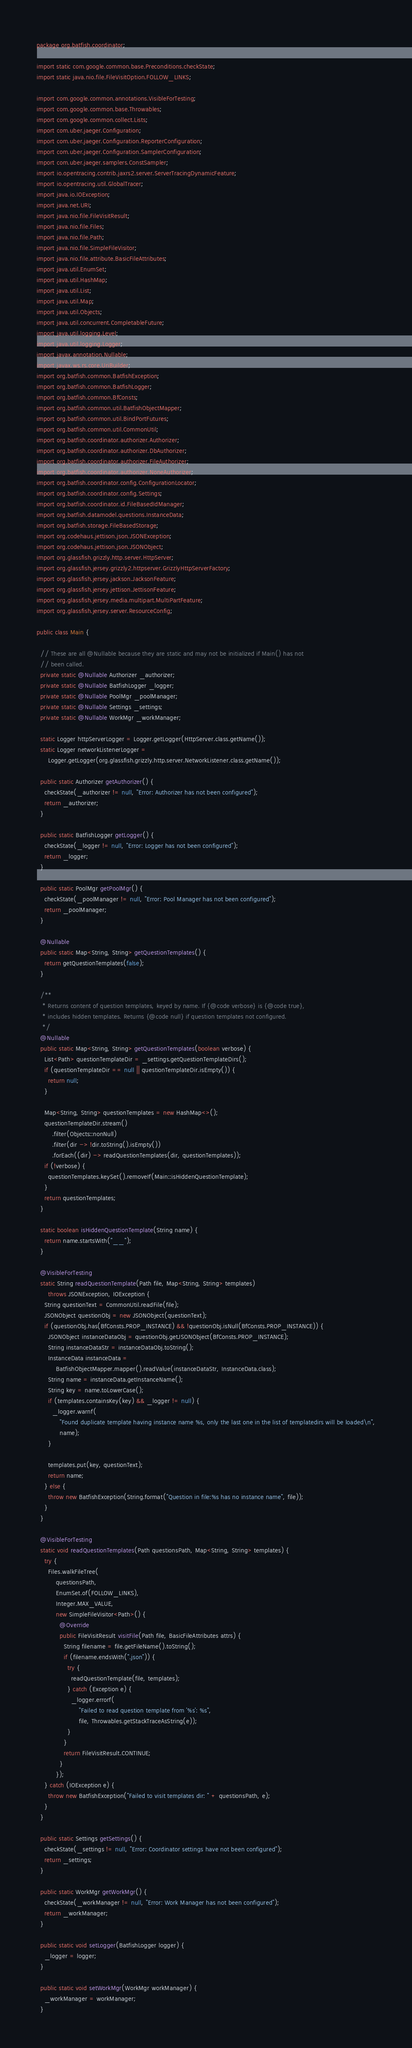<code> <loc_0><loc_0><loc_500><loc_500><_Java_>package org.batfish.coordinator;

import static com.google.common.base.Preconditions.checkState;
import static java.nio.file.FileVisitOption.FOLLOW_LINKS;

import com.google.common.annotations.VisibleForTesting;
import com.google.common.base.Throwables;
import com.google.common.collect.Lists;
import com.uber.jaeger.Configuration;
import com.uber.jaeger.Configuration.ReporterConfiguration;
import com.uber.jaeger.Configuration.SamplerConfiguration;
import com.uber.jaeger.samplers.ConstSampler;
import io.opentracing.contrib.jaxrs2.server.ServerTracingDynamicFeature;
import io.opentracing.util.GlobalTracer;
import java.io.IOException;
import java.net.URI;
import java.nio.file.FileVisitResult;
import java.nio.file.Files;
import java.nio.file.Path;
import java.nio.file.SimpleFileVisitor;
import java.nio.file.attribute.BasicFileAttributes;
import java.util.EnumSet;
import java.util.HashMap;
import java.util.List;
import java.util.Map;
import java.util.Objects;
import java.util.concurrent.CompletableFuture;
import java.util.logging.Level;
import java.util.logging.Logger;
import javax.annotation.Nullable;
import javax.ws.rs.core.UriBuilder;
import org.batfish.common.BatfishException;
import org.batfish.common.BatfishLogger;
import org.batfish.common.BfConsts;
import org.batfish.common.util.BatfishObjectMapper;
import org.batfish.common.util.BindPortFutures;
import org.batfish.common.util.CommonUtil;
import org.batfish.coordinator.authorizer.Authorizer;
import org.batfish.coordinator.authorizer.DbAuthorizer;
import org.batfish.coordinator.authorizer.FileAuthorizer;
import org.batfish.coordinator.authorizer.NoneAuthorizer;
import org.batfish.coordinator.config.ConfigurationLocator;
import org.batfish.coordinator.config.Settings;
import org.batfish.coordinator.id.FileBasedIdManager;
import org.batfish.datamodel.questions.InstanceData;
import org.batfish.storage.FileBasedStorage;
import org.codehaus.jettison.json.JSONException;
import org.codehaus.jettison.json.JSONObject;
import org.glassfish.grizzly.http.server.HttpServer;
import org.glassfish.jersey.grizzly2.httpserver.GrizzlyHttpServerFactory;
import org.glassfish.jersey.jackson.JacksonFeature;
import org.glassfish.jersey.jettison.JettisonFeature;
import org.glassfish.jersey.media.multipart.MultiPartFeature;
import org.glassfish.jersey.server.ResourceConfig;

public class Main {

  // These are all @Nullable because they are static and may not be initialized if Main() has not
  // been called.
  private static @Nullable Authorizer _authorizer;
  private static @Nullable BatfishLogger _logger;
  private static @Nullable PoolMgr _poolManager;
  private static @Nullable Settings _settings;
  private static @Nullable WorkMgr _workManager;

  static Logger httpServerLogger = Logger.getLogger(HttpServer.class.getName());
  static Logger networkListenerLogger =
      Logger.getLogger(org.glassfish.grizzly.http.server.NetworkListener.class.getName());

  public static Authorizer getAuthorizer() {
    checkState(_authorizer != null, "Error: Authorizer has not been configured");
    return _authorizer;
  }

  public static BatfishLogger getLogger() {
    checkState(_logger != null, "Error: Logger has not been configured");
    return _logger;
  }

  public static PoolMgr getPoolMgr() {
    checkState(_poolManager != null, "Error: Pool Manager has not been configured");
    return _poolManager;
  }

  @Nullable
  public static Map<String, String> getQuestionTemplates() {
    return getQuestionTemplates(false);
  }

  /**
   * Returns content of question templates, keyed by name. If {@code verbose} is {@code true},
   * includes hidden templates. Returns {@code null} if question templates not configured.
   */
  @Nullable
  public static Map<String, String> getQuestionTemplates(boolean verbose) {
    List<Path> questionTemplateDir = _settings.getQuestionTemplateDirs();
    if (questionTemplateDir == null || questionTemplateDir.isEmpty()) {
      return null;
    }

    Map<String, String> questionTemplates = new HashMap<>();
    questionTemplateDir.stream()
        .filter(Objects::nonNull)
        .filter(dir -> !dir.toString().isEmpty())
        .forEach((dir) -> readQuestionTemplates(dir, questionTemplates));
    if (!verbose) {
      questionTemplates.keySet().removeIf(Main::isHiddenQuestionTemplate);
    }
    return questionTemplates;
  }

  static boolean isHiddenQuestionTemplate(String name) {
    return name.startsWith("__");
  }

  @VisibleForTesting
  static String readQuestionTemplate(Path file, Map<String, String> templates)
      throws JSONException, IOException {
    String questionText = CommonUtil.readFile(file);
    JSONObject questionObj = new JSONObject(questionText);
    if (questionObj.has(BfConsts.PROP_INSTANCE) && !questionObj.isNull(BfConsts.PROP_INSTANCE)) {
      JSONObject instanceDataObj = questionObj.getJSONObject(BfConsts.PROP_INSTANCE);
      String instanceDataStr = instanceDataObj.toString();
      InstanceData instanceData =
          BatfishObjectMapper.mapper().readValue(instanceDataStr, InstanceData.class);
      String name = instanceData.getInstanceName();
      String key = name.toLowerCase();
      if (templates.containsKey(key) && _logger != null) {
        _logger.warnf(
            "Found duplicate template having instance name %s, only the last one in the list of templatedirs will be loaded\n",
            name);
      }

      templates.put(key, questionText);
      return name;
    } else {
      throw new BatfishException(String.format("Question in file:%s has no instance name", file));
    }
  }

  @VisibleForTesting
  static void readQuestionTemplates(Path questionsPath, Map<String, String> templates) {
    try {
      Files.walkFileTree(
          questionsPath,
          EnumSet.of(FOLLOW_LINKS),
          Integer.MAX_VALUE,
          new SimpleFileVisitor<Path>() {
            @Override
            public FileVisitResult visitFile(Path file, BasicFileAttributes attrs) {
              String filename = file.getFileName().toString();
              if (filename.endsWith(".json")) {
                try {
                  readQuestionTemplate(file, templates);
                } catch (Exception e) {
                  _logger.errorf(
                      "Failed to read question template from '%s': %s",
                      file, Throwables.getStackTraceAsString(e));
                }
              }
              return FileVisitResult.CONTINUE;
            }
          });
    } catch (IOException e) {
      throw new BatfishException("Failed to visit templates dir: " + questionsPath, e);
    }
  }

  public static Settings getSettings() {
    checkState(_settings != null, "Error: Coordinator settings have not been configured");
    return _settings;
  }

  public static WorkMgr getWorkMgr() {
    checkState(_workManager != null, "Error: Work Manager has not been configured");
    return _workManager;
  }

  public static void setLogger(BatfishLogger logger) {
    _logger = logger;
  }

  public static void setWorkMgr(WorkMgr workManager) {
    _workManager = workManager;
  }
</code> 